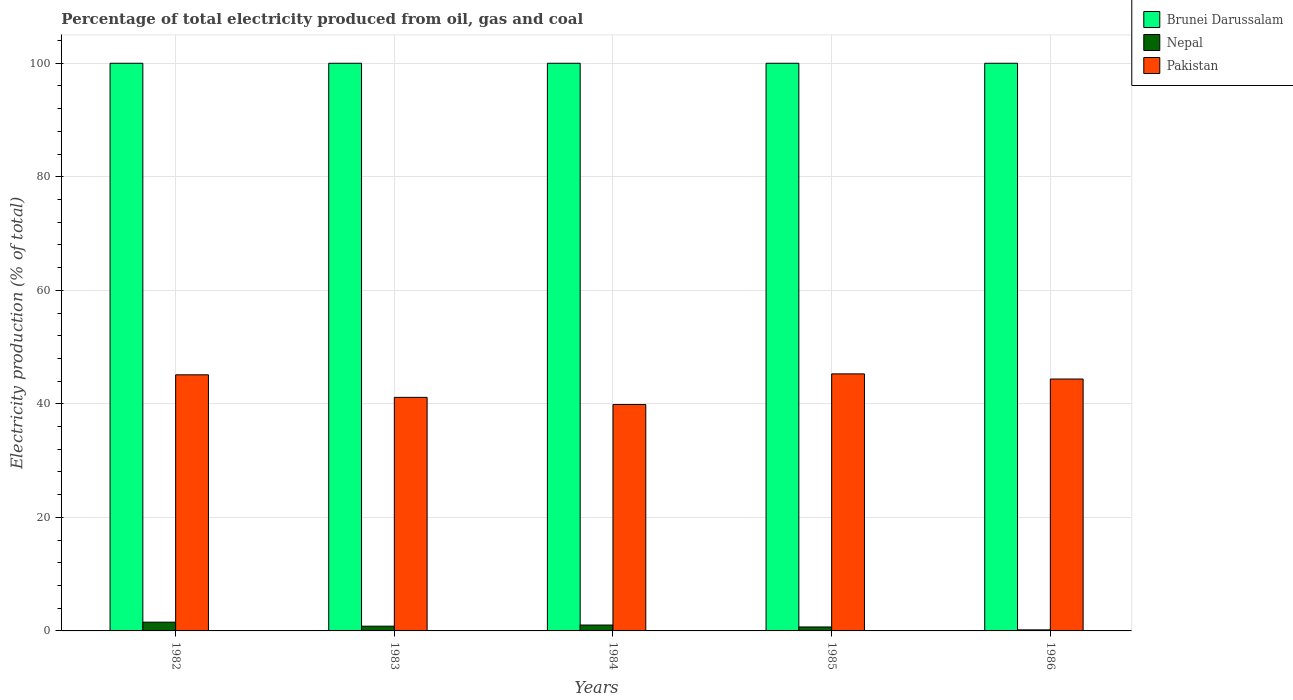How many different coloured bars are there?
Offer a terse response. 3. How many groups of bars are there?
Provide a short and direct response. 5. How many bars are there on the 1st tick from the left?
Make the answer very short. 3. How many bars are there on the 1st tick from the right?
Provide a succinct answer. 3. Across all years, what is the maximum electricity production in in Pakistan?
Provide a succinct answer. 45.28. Across all years, what is the minimum electricity production in in Pakistan?
Provide a succinct answer. 39.88. In which year was the electricity production in in Pakistan maximum?
Offer a terse response. 1985. What is the total electricity production in in Nepal in the graph?
Provide a short and direct response. 4.3. What is the difference between the electricity production in in Brunei Darussalam in 1982 and that in 1986?
Ensure brevity in your answer.  0. What is the difference between the electricity production in in Pakistan in 1986 and the electricity production in in Nepal in 1985?
Provide a succinct answer. 43.68. What is the average electricity production in in Pakistan per year?
Offer a terse response. 43.16. In the year 1982, what is the difference between the electricity production in in Pakistan and electricity production in in Nepal?
Your answer should be very brief. 43.57. What is the ratio of the electricity production in in Pakistan in 1984 to that in 1985?
Give a very brief answer. 0.88. Is the difference between the electricity production in in Pakistan in 1983 and 1984 greater than the difference between the electricity production in in Nepal in 1983 and 1984?
Make the answer very short. Yes. What is the difference between the highest and the second highest electricity production in in Pakistan?
Your answer should be compact. 0.17. What is the difference between the highest and the lowest electricity production in in Pakistan?
Offer a very short reply. 5.4. Is the sum of the electricity production in in Nepal in 1984 and 1986 greater than the maximum electricity production in in Brunei Darussalam across all years?
Provide a short and direct response. No. What does the 1st bar from the left in 1985 represents?
Your response must be concise. Brunei Darussalam. What does the 2nd bar from the right in 1982 represents?
Ensure brevity in your answer.  Nepal. Is it the case that in every year, the sum of the electricity production in in Nepal and electricity production in in Pakistan is greater than the electricity production in in Brunei Darussalam?
Your response must be concise. No. Are all the bars in the graph horizontal?
Offer a terse response. No. Does the graph contain grids?
Offer a very short reply. Yes. Where does the legend appear in the graph?
Your answer should be very brief. Top right. How many legend labels are there?
Your answer should be very brief. 3. What is the title of the graph?
Ensure brevity in your answer.  Percentage of total electricity produced from oil, gas and coal. Does "India" appear as one of the legend labels in the graph?
Keep it short and to the point. No. What is the label or title of the X-axis?
Your answer should be compact. Years. What is the label or title of the Y-axis?
Your answer should be very brief. Electricity production (% of total). What is the Electricity production (% of total) in Brunei Darussalam in 1982?
Your answer should be compact. 100. What is the Electricity production (% of total) in Nepal in 1982?
Provide a succinct answer. 1.54. What is the Electricity production (% of total) of Pakistan in 1982?
Give a very brief answer. 45.12. What is the Electricity production (% of total) in Brunei Darussalam in 1983?
Ensure brevity in your answer.  100. What is the Electricity production (% of total) of Nepal in 1983?
Give a very brief answer. 0.84. What is the Electricity production (% of total) in Pakistan in 1983?
Provide a succinct answer. 41.14. What is the Electricity production (% of total) of Nepal in 1984?
Offer a terse response. 1.04. What is the Electricity production (% of total) of Pakistan in 1984?
Make the answer very short. 39.88. What is the Electricity production (% of total) of Brunei Darussalam in 1985?
Offer a terse response. 100. What is the Electricity production (% of total) in Nepal in 1985?
Your answer should be very brief. 0.7. What is the Electricity production (% of total) in Pakistan in 1985?
Your answer should be compact. 45.28. What is the Electricity production (% of total) of Brunei Darussalam in 1986?
Provide a short and direct response. 100. What is the Electricity production (% of total) of Nepal in 1986?
Give a very brief answer. 0.18. What is the Electricity production (% of total) in Pakistan in 1986?
Offer a terse response. 44.37. Across all years, what is the maximum Electricity production (% of total) of Nepal?
Your response must be concise. 1.54. Across all years, what is the maximum Electricity production (% of total) of Pakistan?
Offer a terse response. 45.28. Across all years, what is the minimum Electricity production (% of total) of Brunei Darussalam?
Ensure brevity in your answer.  100. Across all years, what is the minimum Electricity production (% of total) of Nepal?
Give a very brief answer. 0.18. Across all years, what is the minimum Electricity production (% of total) in Pakistan?
Your response must be concise. 39.88. What is the total Electricity production (% of total) of Nepal in the graph?
Your answer should be very brief. 4.3. What is the total Electricity production (% of total) of Pakistan in the graph?
Provide a short and direct response. 215.79. What is the difference between the Electricity production (% of total) in Nepal in 1982 and that in 1983?
Provide a succinct answer. 0.71. What is the difference between the Electricity production (% of total) of Pakistan in 1982 and that in 1983?
Make the answer very short. 3.97. What is the difference between the Electricity production (% of total) of Nepal in 1982 and that in 1984?
Your answer should be very brief. 0.51. What is the difference between the Electricity production (% of total) in Pakistan in 1982 and that in 1984?
Give a very brief answer. 5.24. What is the difference between the Electricity production (% of total) of Brunei Darussalam in 1982 and that in 1985?
Your answer should be compact. 0. What is the difference between the Electricity production (% of total) in Nepal in 1982 and that in 1985?
Your response must be concise. 0.85. What is the difference between the Electricity production (% of total) in Pakistan in 1982 and that in 1985?
Make the answer very short. -0.17. What is the difference between the Electricity production (% of total) of Brunei Darussalam in 1982 and that in 1986?
Your answer should be compact. 0. What is the difference between the Electricity production (% of total) of Nepal in 1982 and that in 1986?
Offer a very short reply. 1.36. What is the difference between the Electricity production (% of total) of Pakistan in 1982 and that in 1986?
Provide a succinct answer. 0.74. What is the difference between the Electricity production (% of total) in Brunei Darussalam in 1983 and that in 1984?
Your answer should be compact. 0. What is the difference between the Electricity production (% of total) in Nepal in 1983 and that in 1984?
Ensure brevity in your answer.  -0.2. What is the difference between the Electricity production (% of total) in Pakistan in 1983 and that in 1984?
Your answer should be very brief. 1.26. What is the difference between the Electricity production (% of total) of Nepal in 1983 and that in 1985?
Your answer should be compact. 0.14. What is the difference between the Electricity production (% of total) in Pakistan in 1983 and that in 1985?
Provide a short and direct response. -4.14. What is the difference between the Electricity production (% of total) in Nepal in 1983 and that in 1986?
Offer a terse response. 0.65. What is the difference between the Electricity production (% of total) of Pakistan in 1983 and that in 1986?
Make the answer very short. -3.23. What is the difference between the Electricity production (% of total) of Nepal in 1984 and that in 1985?
Provide a short and direct response. 0.34. What is the difference between the Electricity production (% of total) of Pakistan in 1984 and that in 1985?
Offer a very short reply. -5.4. What is the difference between the Electricity production (% of total) of Brunei Darussalam in 1984 and that in 1986?
Provide a short and direct response. 0. What is the difference between the Electricity production (% of total) of Nepal in 1984 and that in 1986?
Provide a short and direct response. 0.85. What is the difference between the Electricity production (% of total) in Pakistan in 1984 and that in 1986?
Provide a short and direct response. -4.49. What is the difference between the Electricity production (% of total) of Brunei Darussalam in 1985 and that in 1986?
Your response must be concise. 0. What is the difference between the Electricity production (% of total) in Nepal in 1985 and that in 1986?
Your answer should be very brief. 0.51. What is the difference between the Electricity production (% of total) of Pakistan in 1985 and that in 1986?
Offer a terse response. 0.91. What is the difference between the Electricity production (% of total) of Brunei Darussalam in 1982 and the Electricity production (% of total) of Nepal in 1983?
Provide a succinct answer. 99.16. What is the difference between the Electricity production (% of total) in Brunei Darussalam in 1982 and the Electricity production (% of total) in Pakistan in 1983?
Provide a short and direct response. 58.86. What is the difference between the Electricity production (% of total) in Nepal in 1982 and the Electricity production (% of total) in Pakistan in 1983?
Your answer should be very brief. -39.6. What is the difference between the Electricity production (% of total) of Brunei Darussalam in 1982 and the Electricity production (% of total) of Nepal in 1984?
Keep it short and to the point. 98.96. What is the difference between the Electricity production (% of total) of Brunei Darussalam in 1982 and the Electricity production (% of total) of Pakistan in 1984?
Give a very brief answer. 60.12. What is the difference between the Electricity production (% of total) in Nepal in 1982 and the Electricity production (% of total) in Pakistan in 1984?
Ensure brevity in your answer.  -38.34. What is the difference between the Electricity production (% of total) of Brunei Darussalam in 1982 and the Electricity production (% of total) of Nepal in 1985?
Your response must be concise. 99.3. What is the difference between the Electricity production (% of total) of Brunei Darussalam in 1982 and the Electricity production (% of total) of Pakistan in 1985?
Keep it short and to the point. 54.72. What is the difference between the Electricity production (% of total) of Nepal in 1982 and the Electricity production (% of total) of Pakistan in 1985?
Ensure brevity in your answer.  -43.74. What is the difference between the Electricity production (% of total) in Brunei Darussalam in 1982 and the Electricity production (% of total) in Nepal in 1986?
Provide a succinct answer. 99.82. What is the difference between the Electricity production (% of total) of Brunei Darussalam in 1982 and the Electricity production (% of total) of Pakistan in 1986?
Give a very brief answer. 55.63. What is the difference between the Electricity production (% of total) of Nepal in 1982 and the Electricity production (% of total) of Pakistan in 1986?
Give a very brief answer. -42.83. What is the difference between the Electricity production (% of total) in Brunei Darussalam in 1983 and the Electricity production (% of total) in Nepal in 1984?
Offer a very short reply. 98.96. What is the difference between the Electricity production (% of total) of Brunei Darussalam in 1983 and the Electricity production (% of total) of Pakistan in 1984?
Your answer should be very brief. 60.12. What is the difference between the Electricity production (% of total) in Nepal in 1983 and the Electricity production (% of total) in Pakistan in 1984?
Give a very brief answer. -39.04. What is the difference between the Electricity production (% of total) in Brunei Darussalam in 1983 and the Electricity production (% of total) in Nepal in 1985?
Offer a very short reply. 99.3. What is the difference between the Electricity production (% of total) of Brunei Darussalam in 1983 and the Electricity production (% of total) of Pakistan in 1985?
Your response must be concise. 54.72. What is the difference between the Electricity production (% of total) in Nepal in 1983 and the Electricity production (% of total) in Pakistan in 1985?
Your answer should be compact. -44.45. What is the difference between the Electricity production (% of total) in Brunei Darussalam in 1983 and the Electricity production (% of total) in Nepal in 1986?
Your answer should be very brief. 99.82. What is the difference between the Electricity production (% of total) in Brunei Darussalam in 1983 and the Electricity production (% of total) in Pakistan in 1986?
Keep it short and to the point. 55.63. What is the difference between the Electricity production (% of total) in Nepal in 1983 and the Electricity production (% of total) in Pakistan in 1986?
Your answer should be very brief. -43.54. What is the difference between the Electricity production (% of total) in Brunei Darussalam in 1984 and the Electricity production (% of total) in Nepal in 1985?
Make the answer very short. 99.3. What is the difference between the Electricity production (% of total) of Brunei Darussalam in 1984 and the Electricity production (% of total) of Pakistan in 1985?
Offer a terse response. 54.72. What is the difference between the Electricity production (% of total) in Nepal in 1984 and the Electricity production (% of total) in Pakistan in 1985?
Your response must be concise. -44.24. What is the difference between the Electricity production (% of total) in Brunei Darussalam in 1984 and the Electricity production (% of total) in Nepal in 1986?
Offer a terse response. 99.82. What is the difference between the Electricity production (% of total) of Brunei Darussalam in 1984 and the Electricity production (% of total) of Pakistan in 1986?
Offer a terse response. 55.63. What is the difference between the Electricity production (% of total) of Nepal in 1984 and the Electricity production (% of total) of Pakistan in 1986?
Your answer should be compact. -43.34. What is the difference between the Electricity production (% of total) of Brunei Darussalam in 1985 and the Electricity production (% of total) of Nepal in 1986?
Provide a short and direct response. 99.82. What is the difference between the Electricity production (% of total) of Brunei Darussalam in 1985 and the Electricity production (% of total) of Pakistan in 1986?
Give a very brief answer. 55.63. What is the difference between the Electricity production (% of total) in Nepal in 1985 and the Electricity production (% of total) in Pakistan in 1986?
Make the answer very short. -43.68. What is the average Electricity production (% of total) of Nepal per year?
Your answer should be very brief. 0.86. What is the average Electricity production (% of total) in Pakistan per year?
Provide a succinct answer. 43.16. In the year 1982, what is the difference between the Electricity production (% of total) of Brunei Darussalam and Electricity production (% of total) of Nepal?
Provide a short and direct response. 98.46. In the year 1982, what is the difference between the Electricity production (% of total) of Brunei Darussalam and Electricity production (% of total) of Pakistan?
Give a very brief answer. 54.88. In the year 1982, what is the difference between the Electricity production (% of total) of Nepal and Electricity production (% of total) of Pakistan?
Your answer should be very brief. -43.57. In the year 1983, what is the difference between the Electricity production (% of total) of Brunei Darussalam and Electricity production (% of total) of Nepal?
Provide a short and direct response. 99.16. In the year 1983, what is the difference between the Electricity production (% of total) of Brunei Darussalam and Electricity production (% of total) of Pakistan?
Provide a short and direct response. 58.86. In the year 1983, what is the difference between the Electricity production (% of total) in Nepal and Electricity production (% of total) in Pakistan?
Provide a short and direct response. -40.31. In the year 1984, what is the difference between the Electricity production (% of total) of Brunei Darussalam and Electricity production (% of total) of Nepal?
Ensure brevity in your answer.  98.96. In the year 1984, what is the difference between the Electricity production (% of total) of Brunei Darussalam and Electricity production (% of total) of Pakistan?
Your answer should be compact. 60.12. In the year 1984, what is the difference between the Electricity production (% of total) of Nepal and Electricity production (% of total) of Pakistan?
Provide a short and direct response. -38.84. In the year 1985, what is the difference between the Electricity production (% of total) in Brunei Darussalam and Electricity production (% of total) in Nepal?
Give a very brief answer. 99.3. In the year 1985, what is the difference between the Electricity production (% of total) in Brunei Darussalam and Electricity production (% of total) in Pakistan?
Make the answer very short. 54.72. In the year 1985, what is the difference between the Electricity production (% of total) in Nepal and Electricity production (% of total) in Pakistan?
Provide a short and direct response. -44.58. In the year 1986, what is the difference between the Electricity production (% of total) of Brunei Darussalam and Electricity production (% of total) of Nepal?
Provide a short and direct response. 99.82. In the year 1986, what is the difference between the Electricity production (% of total) in Brunei Darussalam and Electricity production (% of total) in Pakistan?
Provide a succinct answer. 55.63. In the year 1986, what is the difference between the Electricity production (% of total) of Nepal and Electricity production (% of total) of Pakistan?
Your answer should be very brief. -44.19. What is the ratio of the Electricity production (% of total) in Nepal in 1982 to that in 1983?
Make the answer very short. 1.85. What is the ratio of the Electricity production (% of total) of Pakistan in 1982 to that in 1983?
Ensure brevity in your answer.  1.1. What is the ratio of the Electricity production (% of total) in Brunei Darussalam in 1982 to that in 1984?
Make the answer very short. 1. What is the ratio of the Electricity production (% of total) of Nepal in 1982 to that in 1984?
Make the answer very short. 1.49. What is the ratio of the Electricity production (% of total) in Pakistan in 1982 to that in 1984?
Provide a short and direct response. 1.13. What is the ratio of the Electricity production (% of total) of Brunei Darussalam in 1982 to that in 1985?
Offer a very short reply. 1. What is the ratio of the Electricity production (% of total) of Nepal in 1982 to that in 1985?
Keep it short and to the point. 2.21. What is the ratio of the Electricity production (% of total) of Nepal in 1982 to that in 1986?
Offer a terse response. 8.35. What is the ratio of the Electricity production (% of total) of Pakistan in 1982 to that in 1986?
Make the answer very short. 1.02. What is the ratio of the Electricity production (% of total) in Brunei Darussalam in 1983 to that in 1984?
Provide a succinct answer. 1. What is the ratio of the Electricity production (% of total) in Nepal in 1983 to that in 1984?
Your answer should be very brief. 0.81. What is the ratio of the Electricity production (% of total) in Pakistan in 1983 to that in 1984?
Provide a succinct answer. 1.03. What is the ratio of the Electricity production (% of total) in Nepal in 1983 to that in 1985?
Provide a short and direct response. 1.2. What is the ratio of the Electricity production (% of total) in Pakistan in 1983 to that in 1985?
Provide a short and direct response. 0.91. What is the ratio of the Electricity production (% of total) in Nepal in 1983 to that in 1986?
Provide a succinct answer. 4.52. What is the ratio of the Electricity production (% of total) in Pakistan in 1983 to that in 1986?
Keep it short and to the point. 0.93. What is the ratio of the Electricity production (% of total) of Brunei Darussalam in 1984 to that in 1985?
Give a very brief answer. 1. What is the ratio of the Electricity production (% of total) of Nepal in 1984 to that in 1985?
Offer a terse response. 1.49. What is the ratio of the Electricity production (% of total) of Pakistan in 1984 to that in 1985?
Provide a succinct answer. 0.88. What is the ratio of the Electricity production (% of total) in Brunei Darussalam in 1984 to that in 1986?
Keep it short and to the point. 1. What is the ratio of the Electricity production (% of total) of Nepal in 1984 to that in 1986?
Make the answer very short. 5.61. What is the ratio of the Electricity production (% of total) of Pakistan in 1984 to that in 1986?
Ensure brevity in your answer.  0.9. What is the ratio of the Electricity production (% of total) in Nepal in 1985 to that in 1986?
Your answer should be compact. 3.77. What is the ratio of the Electricity production (% of total) in Pakistan in 1985 to that in 1986?
Ensure brevity in your answer.  1.02. What is the difference between the highest and the second highest Electricity production (% of total) of Nepal?
Ensure brevity in your answer.  0.51. What is the difference between the highest and the second highest Electricity production (% of total) of Pakistan?
Provide a succinct answer. 0.17. What is the difference between the highest and the lowest Electricity production (% of total) of Brunei Darussalam?
Give a very brief answer. 0. What is the difference between the highest and the lowest Electricity production (% of total) in Nepal?
Provide a short and direct response. 1.36. What is the difference between the highest and the lowest Electricity production (% of total) of Pakistan?
Provide a succinct answer. 5.4. 